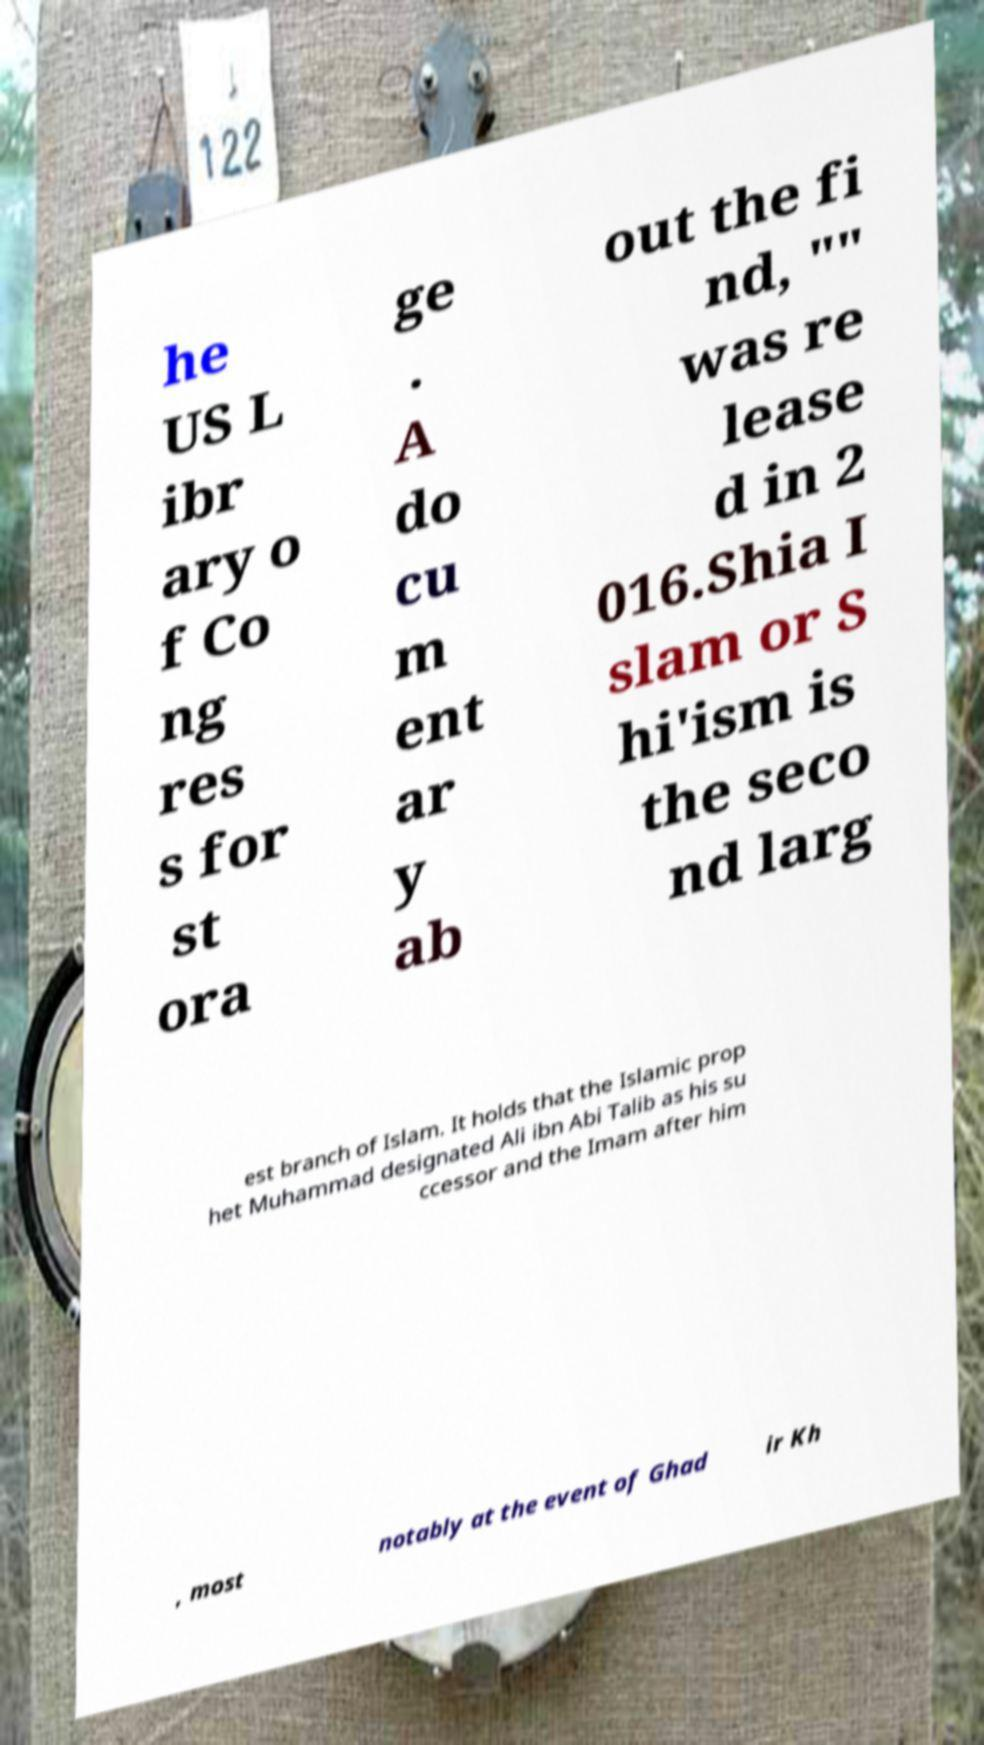Please identify and transcribe the text found in this image. he US L ibr ary o f Co ng res s for st ora ge . A do cu m ent ar y ab out the fi nd, "" was re lease d in 2 016.Shia I slam or S hi'ism is the seco nd larg est branch of Islam. It holds that the Islamic prop het Muhammad designated Ali ibn Abi Talib as his su ccessor and the Imam after him , most notably at the event of Ghad ir Kh 